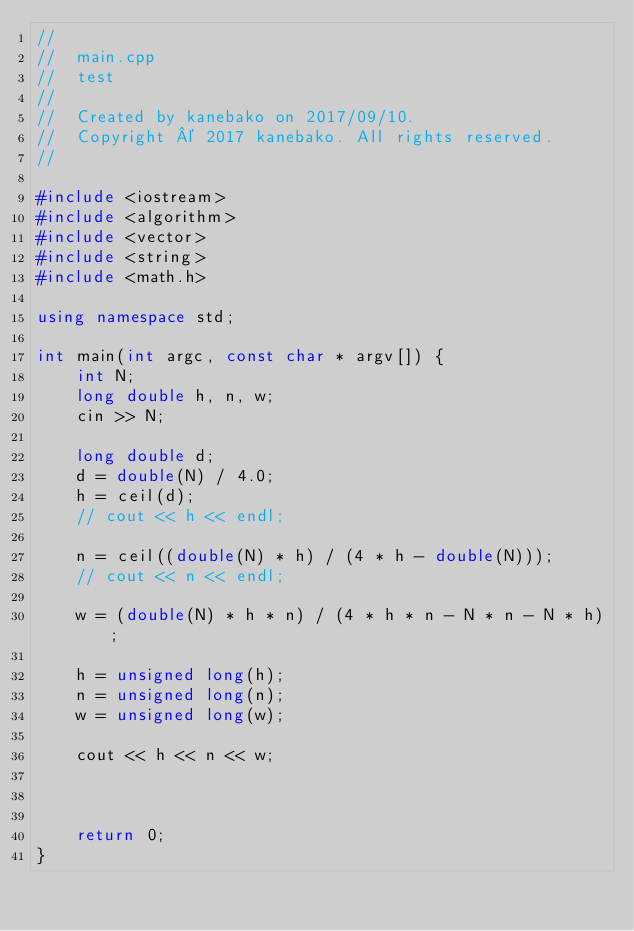<code> <loc_0><loc_0><loc_500><loc_500><_C++_>//
//  main.cpp
//  test
//
//  Created by kanebako on 2017/09/10.
//  Copyright © 2017 kanebako. All rights reserved.
//

#include <iostream>
#include <algorithm>
#include <vector>
#include <string>
#include <math.h>

using namespace std;

int main(int argc, const char * argv[]) {
    int N;
    long double h, n, w;
    cin >> N;
    
    long double d;
    d = double(N) / 4.0;
    h = ceil(d);
    // cout << h << endl;
    
    n = ceil((double(N) * h) / (4 * h - double(N)));
    // cout << n << endl;
    
    w = (double(N) * h * n) / (4 * h * n - N * n - N * h);
    
    h = unsigned long(h);
    n = unsigned long(n);
    w = unsigned long(w);
    
    cout << h << n << w;
    
    

    return 0;
}
</code> 